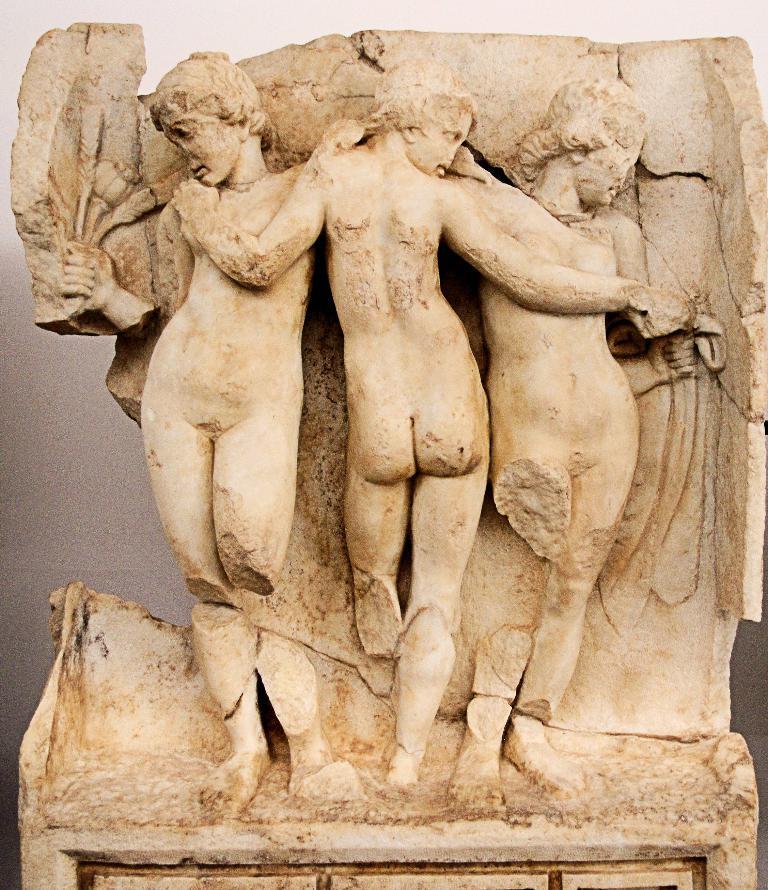Please provide a concise description of this image. The picture consists of a sculpture on a stone. In the background there is a wall painted in white. 